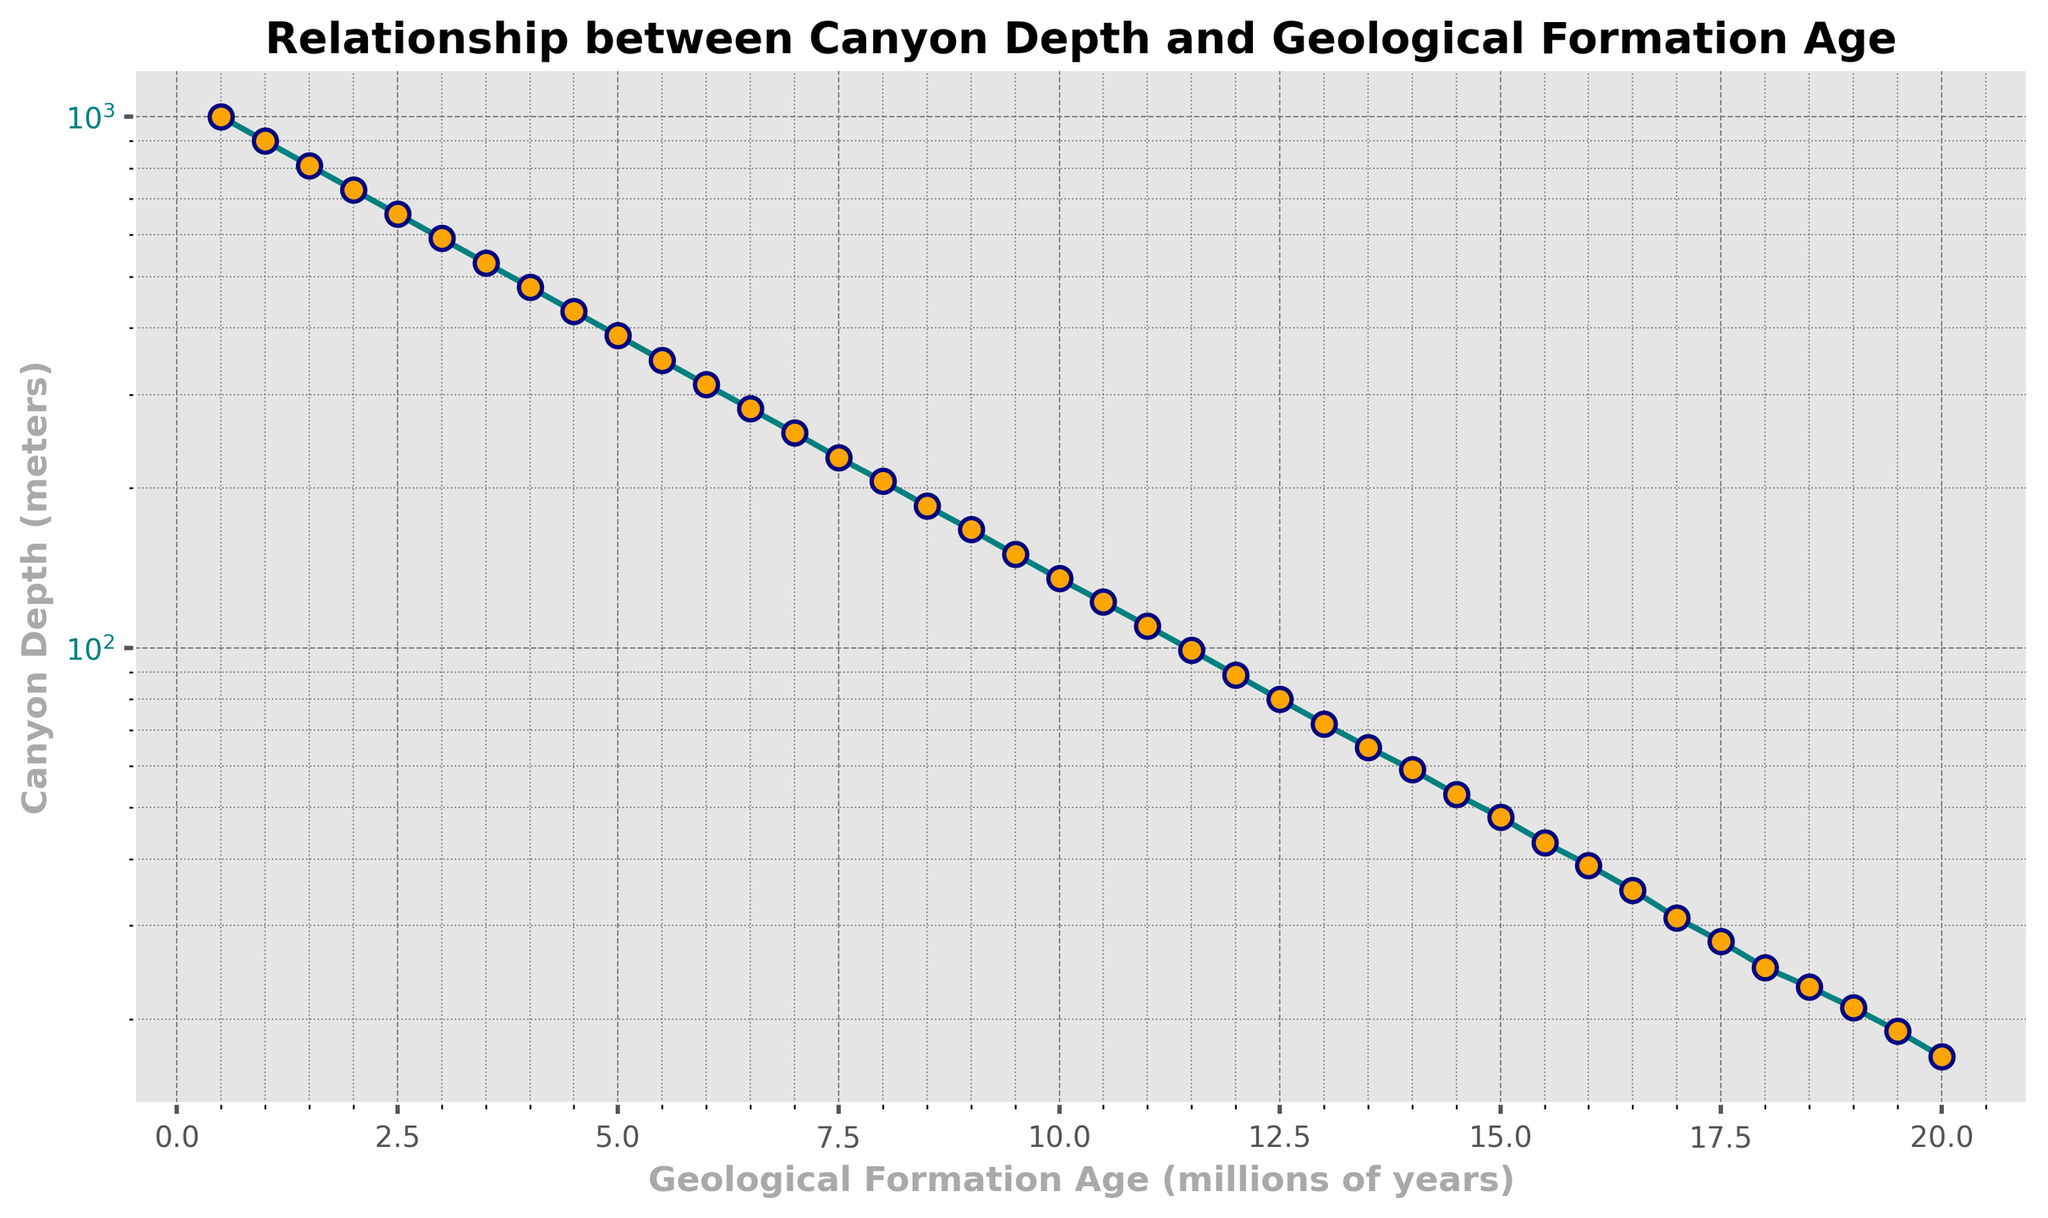What's the depth of the canyon at 2.5 million years? Refer to the 'age' value of 2.5 on the x-axis, then go up to intersect the curve and read the 'depth' value on the y-axis. The value is 656 meters.
Answer: 656 meters How does the depth of the canyon at 4.0 million years compare to its depth at 8.0 million years? At 4.0 million years, the depth is 478 meters. At 8.0 million years, the depth is 206 meters. Comparing them, the depth at 4.0 million years is greater.
Answer: 478 > 206 By how much does the canyon depth decrease from 5.0 million years to 10.0 million years? The depth at 5.0 million years is 387 meters. The depth at 10.0 million years is 135 meters. Subtract the depth at 10.0 million years from the depth at 5.0 million years: 387 - 135 = 252 meters.
Answer: 252 meters Which geological formation age shows the fastest rate of depth decrease? By visually inspecting the steepness of the curve, the largest change in depth occurs from 0.5 million years to around 3.5 million years, where the curve is steepest.
Answer: 0.5 to 3.5 million years What are the visual cues that indicate the nature of the relationship between canyon depth and geological formation age? The plot shows a curve with a steep decline initially and flattening out later, indicating an exponential decay relationship where the rate of depth decrease slows down over time. The color and markers emphasize the changes over time.
Answer: Exponential decay pattern What's the average canyon depth between 6.0 and 12.0 million years? Find the depth values at 6.0, 7.0, 8.0, 9.0, 10.0, 11.0, and 12.0 million years. These values are 313, 254, 206, 167, 135, 110, and 89 meters respectively. Sum these values and divide by the number of data points (7): (313 + 254 + 206 + 167 + 135 + 110 + 89) / 7 = 1820 / 7 = 260.
Answer: 260 meters At what ages does the depth fall below 100 meters? The depth falls below 100 meters starting at the age of 11.5 million years on the plot.
Answer: 11.5 million years What is the depth of the canyon at the median geological formation age? The median age of the given range (0.5 to 20.0 million years) is at the mid-point, which is approximately 10.25 million years. Estimating between 10.0 and 10.5 million years when depth is around 135 to 122 meters, the median depth is around 128.
Answer: 128 meters 